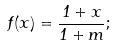Convert formula to latex. <formula><loc_0><loc_0><loc_500><loc_500>f ( x ) = \frac { 1 + x } { 1 + m } ;</formula> 